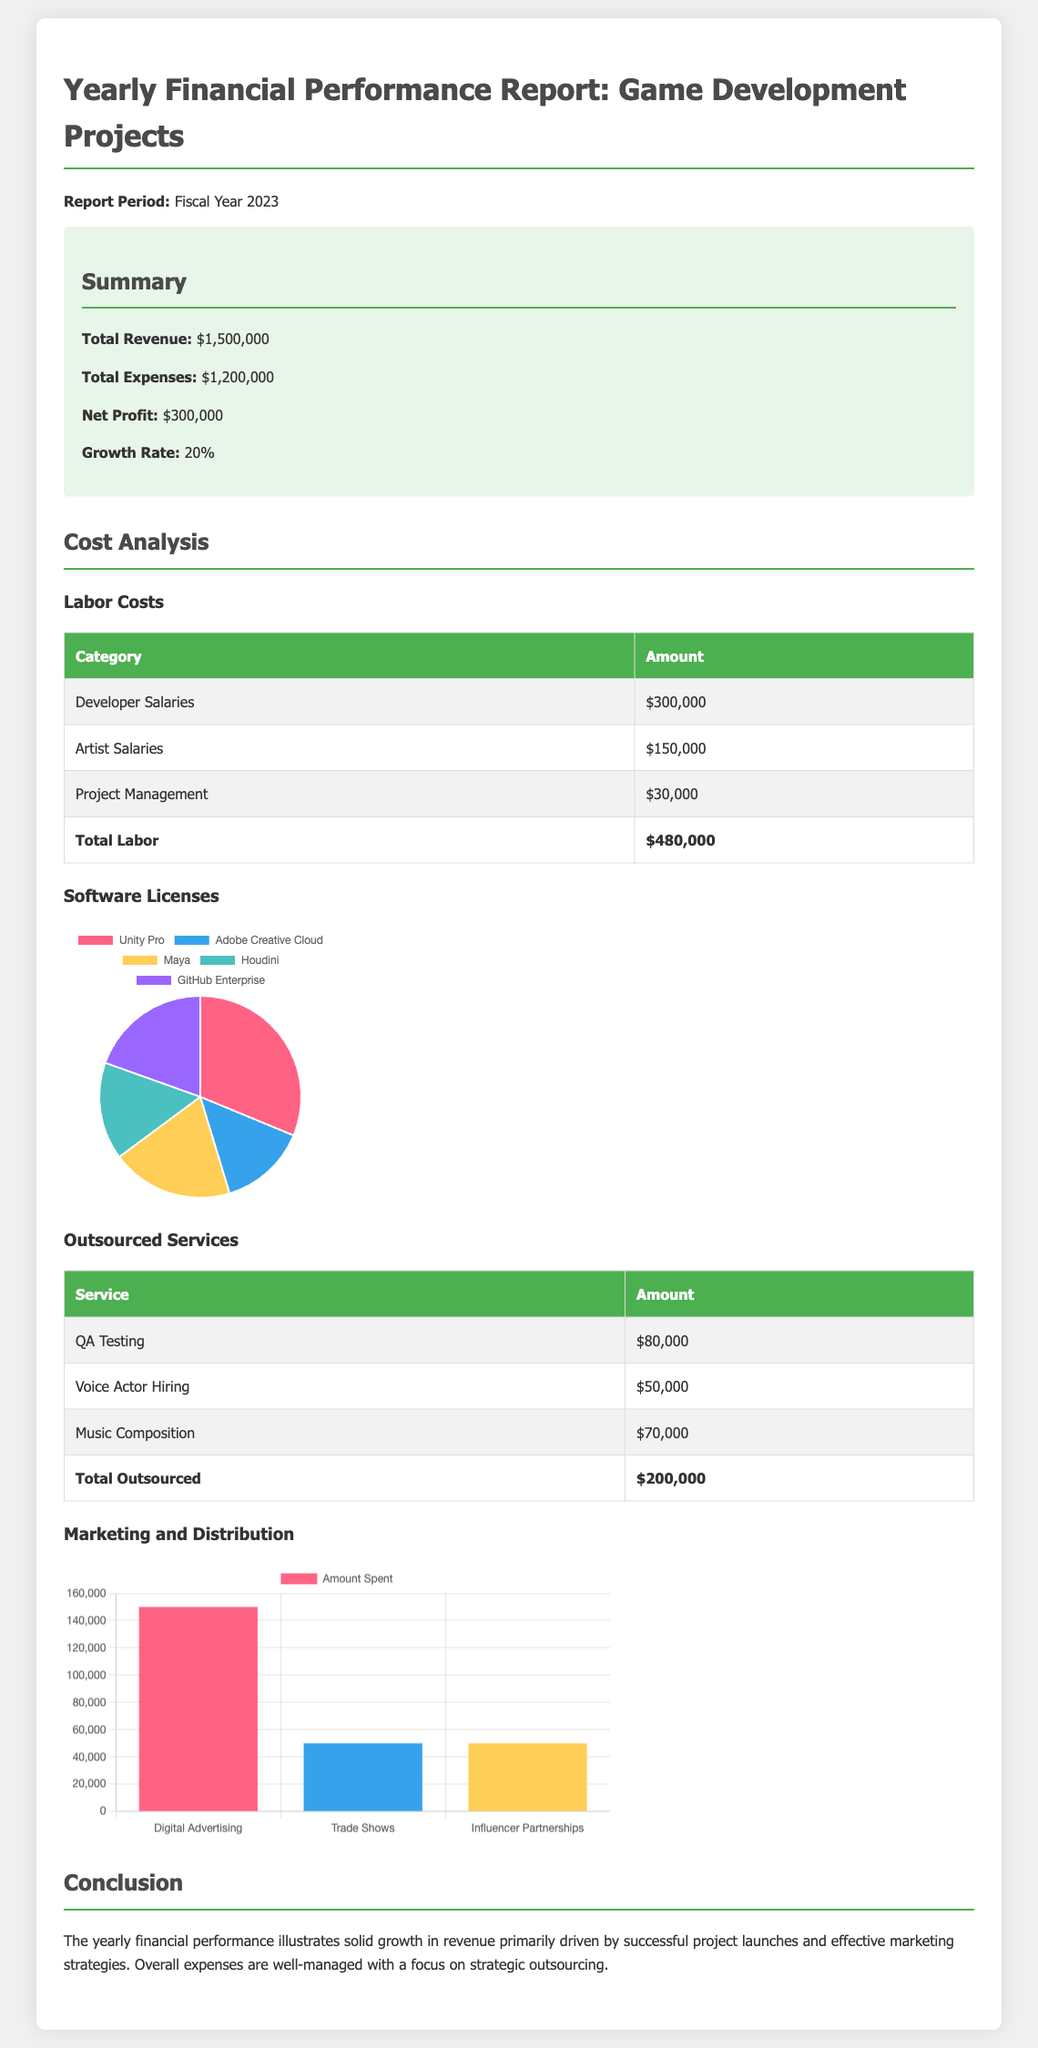What is the total revenue? The total revenue is stated in the summary section of the document, which indicates it is $1,500,000.
Answer: $1,500,000 What were the total labor costs? The total labor costs are shown in the cost analysis section, summing up to $480,000.
Answer: $480,000 How much was spent on QA Testing? The amount spent on QA Testing is detailed in the outsourced services section and is listed as $80,000.
Answer: $80,000 What is the net profit? The net profit is derived from subtracting total expenses from total revenue, and is reported as $300,000.
Answer: $300,000 What is the growth rate percentage? The growth rate is provided in the summary section and is indicated as 20%.
Answer: 20% How much was allocated for Unity Pro licenses? The allocation for Unity Pro is specifically listed in the software licenses chart as $40,000.
Answer: $40,000 Which category had the highest cost in labor? The labor category with the highest cost, as presented, is Developer Salaries amounting to $300,000.
Answer: Developer Salaries What are the three marketing strategies listed? The three marketing strategies are detailed in the marketing chart and include Digital Advertising, Trade Shows, and Influencer Partnerships.
Answer: Digital Advertising, Trade Shows, Influencer Partnerships What was the total amount spent on outsourced services? The total amount spent on outsourced services is summarized in the cost analysis as $200,000.
Answer: $200,000 What color represents Adobe Creative Cloud in the chart? The color representing Adobe Creative Cloud in the software licenses chart is blue.
Answer: Blue 